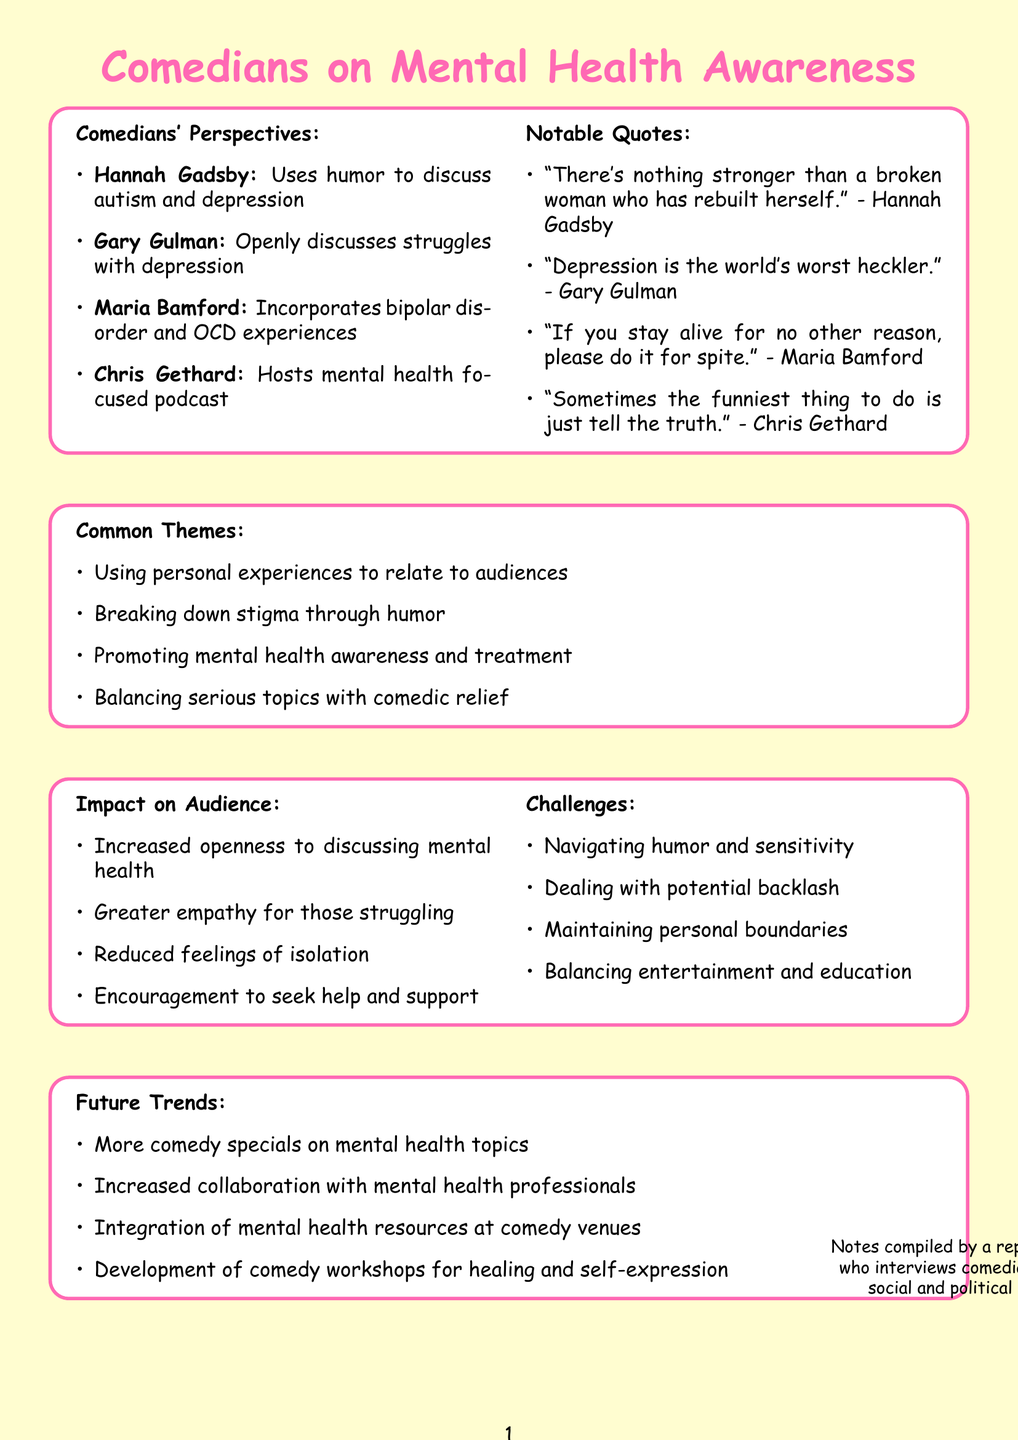What is the name of the comedian who uses humor to discuss autism and depression? The document identifies Hannah Gadsby as the comedian who uses humor to discuss her experiences with autism and depression.
Answer: Hannah Gadsby What key mental health issue does Gary Gulman openly discuss in his comedy? The document states that Gary Gulman openly discusses his struggles with depression in his comedy specials.
Answer: Depression Which comedian incorporates experiences with bipolar disorder into their comedy? The document mentions Maria Bamford as the comedian who incorporates her experiences with bipolar disorder and OCD into her comedy.
Answer: Maria Bamford What is one common theme highlighted in the document regarding comedians addressing mental health? The document lists "breaking down stigma through humor" as one of the common themes among comedians addressing mental health.
Answer: Breaking down stigma through humor What impact does using humor to discuss mental health have on the audience? The document highlights that using humor leads to increased openness to discussing mental health among the audience.
Answer: Increased openness to discussing mental health What challenge do comedians face when discussing sensitive mental health topics? The document mentions "navigating the line between humor and sensitivity" as one of the challenges comedians encounter.
Answer: Navigating the line between humor and sensitivity What future trend is anticipated in the comedy industry regarding mental health? The document predicts that there will be more comedy specials dedicated to mental health topics in the future.
Answer: More comedy specials dedicated to mental health topics Who hosts a podcast focused on mental health and comedy? The document indicates that Chris Gethard hosts a podcast focused on mental health and comedy.
Answer: Chris Gethard What is Maria Bamford's notable quote related to mental health? The document lists Maria Bamford's notable quote as "If you stay alive for no other reason, please do it for spite."
Answer: If you stay alive for no other reason, please do it for spite 